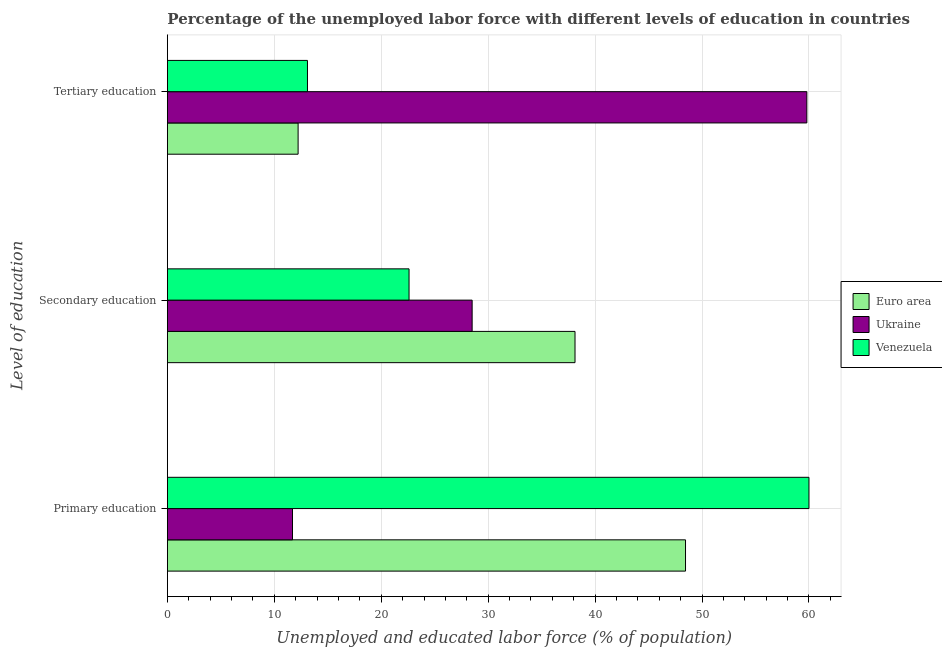How many different coloured bars are there?
Your answer should be very brief. 3. How many groups of bars are there?
Ensure brevity in your answer.  3. How many bars are there on the 3rd tick from the bottom?
Your answer should be very brief. 3. What is the label of the 3rd group of bars from the top?
Keep it short and to the point. Primary education. What is the percentage of labor force who received primary education in Ukraine?
Give a very brief answer. 11.7. Across all countries, what is the maximum percentage of labor force who received tertiary education?
Your answer should be compact. 59.8. Across all countries, what is the minimum percentage of labor force who received primary education?
Provide a succinct answer. 11.7. In which country was the percentage of labor force who received primary education maximum?
Keep it short and to the point. Venezuela. In which country was the percentage of labor force who received secondary education minimum?
Give a very brief answer. Venezuela. What is the total percentage of labor force who received secondary education in the graph?
Provide a succinct answer. 89.22. What is the difference between the percentage of labor force who received tertiary education in Ukraine and that in Venezuela?
Provide a succinct answer. 46.7. What is the difference between the percentage of labor force who received secondary education in Ukraine and the percentage of labor force who received primary education in Euro area?
Your response must be concise. -19.95. What is the average percentage of labor force who received secondary education per country?
Your answer should be very brief. 29.74. What is the difference between the percentage of labor force who received primary education and percentage of labor force who received tertiary education in Euro area?
Your answer should be compact. 36.23. In how many countries, is the percentage of labor force who received primary education greater than 16 %?
Give a very brief answer. 2. What is the ratio of the percentage of labor force who received tertiary education in Euro area to that in Venezuela?
Offer a terse response. 0.93. Is the percentage of labor force who received secondary education in Ukraine less than that in Venezuela?
Make the answer very short. No. What is the difference between the highest and the second highest percentage of labor force who received primary education?
Offer a terse response. 11.55. What is the difference between the highest and the lowest percentage of labor force who received secondary education?
Give a very brief answer. 15.52. Is the sum of the percentage of labor force who received secondary education in Ukraine and Venezuela greater than the maximum percentage of labor force who received tertiary education across all countries?
Offer a terse response. No. What does the 1st bar from the top in Primary education represents?
Your response must be concise. Venezuela. What does the 3rd bar from the bottom in Secondary education represents?
Make the answer very short. Venezuela. Is it the case that in every country, the sum of the percentage of labor force who received primary education and percentage of labor force who received secondary education is greater than the percentage of labor force who received tertiary education?
Your answer should be compact. No. How many countries are there in the graph?
Your response must be concise. 3. What is the difference between two consecutive major ticks on the X-axis?
Offer a very short reply. 10. Does the graph contain grids?
Keep it short and to the point. Yes. What is the title of the graph?
Keep it short and to the point. Percentage of the unemployed labor force with different levels of education in countries. What is the label or title of the X-axis?
Provide a succinct answer. Unemployed and educated labor force (% of population). What is the label or title of the Y-axis?
Provide a short and direct response. Level of education. What is the Unemployed and educated labor force (% of population) in Euro area in Primary education?
Your answer should be compact. 48.45. What is the Unemployed and educated labor force (% of population) in Ukraine in Primary education?
Your answer should be very brief. 11.7. What is the Unemployed and educated labor force (% of population) of Euro area in Secondary education?
Offer a very short reply. 38.12. What is the Unemployed and educated labor force (% of population) of Ukraine in Secondary education?
Keep it short and to the point. 28.5. What is the Unemployed and educated labor force (% of population) in Venezuela in Secondary education?
Ensure brevity in your answer.  22.6. What is the Unemployed and educated labor force (% of population) of Euro area in Tertiary education?
Give a very brief answer. 12.23. What is the Unemployed and educated labor force (% of population) of Ukraine in Tertiary education?
Ensure brevity in your answer.  59.8. What is the Unemployed and educated labor force (% of population) of Venezuela in Tertiary education?
Provide a succinct answer. 13.1. Across all Level of education, what is the maximum Unemployed and educated labor force (% of population) of Euro area?
Give a very brief answer. 48.45. Across all Level of education, what is the maximum Unemployed and educated labor force (% of population) of Ukraine?
Ensure brevity in your answer.  59.8. Across all Level of education, what is the maximum Unemployed and educated labor force (% of population) in Venezuela?
Provide a succinct answer. 60. Across all Level of education, what is the minimum Unemployed and educated labor force (% of population) in Euro area?
Offer a very short reply. 12.23. Across all Level of education, what is the minimum Unemployed and educated labor force (% of population) of Ukraine?
Your response must be concise. 11.7. Across all Level of education, what is the minimum Unemployed and educated labor force (% of population) of Venezuela?
Your answer should be compact. 13.1. What is the total Unemployed and educated labor force (% of population) in Euro area in the graph?
Your answer should be compact. 98.8. What is the total Unemployed and educated labor force (% of population) of Ukraine in the graph?
Your response must be concise. 100. What is the total Unemployed and educated labor force (% of population) of Venezuela in the graph?
Make the answer very short. 95.7. What is the difference between the Unemployed and educated labor force (% of population) in Euro area in Primary education and that in Secondary education?
Give a very brief answer. 10.33. What is the difference between the Unemployed and educated labor force (% of population) in Ukraine in Primary education and that in Secondary education?
Your answer should be very brief. -16.8. What is the difference between the Unemployed and educated labor force (% of population) of Venezuela in Primary education and that in Secondary education?
Provide a succinct answer. 37.4. What is the difference between the Unemployed and educated labor force (% of population) in Euro area in Primary education and that in Tertiary education?
Provide a succinct answer. 36.23. What is the difference between the Unemployed and educated labor force (% of population) in Ukraine in Primary education and that in Tertiary education?
Offer a very short reply. -48.1. What is the difference between the Unemployed and educated labor force (% of population) in Venezuela in Primary education and that in Tertiary education?
Keep it short and to the point. 46.9. What is the difference between the Unemployed and educated labor force (% of population) of Euro area in Secondary education and that in Tertiary education?
Offer a terse response. 25.9. What is the difference between the Unemployed and educated labor force (% of population) in Ukraine in Secondary education and that in Tertiary education?
Keep it short and to the point. -31.3. What is the difference between the Unemployed and educated labor force (% of population) of Venezuela in Secondary education and that in Tertiary education?
Your answer should be very brief. 9.5. What is the difference between the Unemployed and educated labor force (% of population) in Euro area in Primary education and the Unemployed and educated labor force (% of population) in Ukraine in Secondary education?
Your answer should be compact. 19.95. What is the difference between the Unemployed and educated labor force (% of population) in Euro area in Primary education and the Unemployed and educated labor force (% of population) in Venezuela in Secondary education?
Keep it short and to the point. 25.85. What is the difference between the Unemployed and educated labor force (% of population) in Ukraine in Primary education and the Unemployed and educated labor force (% of population) in Venezuela in Secondary education?
Provide a short and direct response. -10.9. What is the difference between the Unemployed and educated labor force (% of population) in Euro area in Primary education and the Unemployed and educated labor force (% of population) in Ukraine in Tertiary education?
Ensure brevity in your answer.  -11.35. What is the difference between the Unemployed and educated labor force (% of population) of Euro area in Primary education and the Unemployed and educated labor force (% of population) of Venezuela in Tertiary education?
Your answer should be very brief. 35.35. What is the difference between the Unemployed and educated labor force (% of population) in Euro area in Secondary education and the Unemployed and educated labor force (% of population) in Ukraine in Tertiary education?
Provide a short and direct response. -21.68. What is the difference between the Unemployed and educated labor force (% of population) in Euro area in Secondary education and the Unemployed and educated labor force (% of population) in Venezuela in Tertiary education?
Your answer should be very brief. 25.02. What is the average Unemployed and educated labor force (% of population) in Euro area per Level of education?
Your answer should be compact. 32.93. What is the average Unemployed and educated labor force (% of population) of Ukraine per Level of education?
Offer a terse response. 33.33. What is the average Unemployed and educated labor force (% of population) of Venezuela per Level of education?
Your response must be concise. 31.9. What is the difference between the Unemployed and educated labor force (% of population) of Euro area and Unemployed and educated labor force (% of population) of Ukraine in Primary education?
Keep it short and to the point. 36.75. What is the difference between the Unemployed and educated labor force (% of population) in Euro area and Unemployed and educated labor force (% of population) in Venezuela in Primary education?
Make the answer very short. -11.55. What is the difference between the Unemployed and educated labor force (% of population) in Ukraine and Unemployed and educated labor force (% of population) in Venezuela in Primary education?
Give a very brief answer. -48.3. What is the difference between the Unemployed and educated labor force (% of population) of Euro area and Unemployed and educated labor force (% of population) of Ukraine in Secondary education?
Provide a short and direct response. 9.62. What is the difference between the Unemployed and educated labor force (% of population) of Euro area and Unemployed and educated labor force (% of population) of Venezuela in Secondary education?
Your answer should be very brief. 15.52. What is the difference between the Unemployed and educated labor force (% of population) in Euro area and Unemployed and educated labor force (% of population) in Ukraine in Tertiary education?
Offer a terse response. -47.57. What is the difference between the Unemployed and educated labor force (% of population) of Euro area and Unemployed and educated labor force (% of population) of Venezuela in Tertiary education?
Your response must be concise. -0.87. What is the difference between the Unemployed and educated labor force (% of population) of Ukraine and Unemployed and educated labor force (% of population) of Venezuela in Tertiary education?
Make the answer very short. 46.7. What is the ratio of the Unemployed and educated labor force (% of population) of Euro area in Primary education to that in Secondary education?
Your answer should be compact. 1.27. What is the ratio of the Unemployed and educated labor force (% of population) in Ukraine in Primary education to that in Secondary education?
Give a very brief answer. 0.41. What is the ratio of the Unemployed and educated labor force (% of population) of Venezuela in Primary education to that in Secondary education?
Provide a succinct answer. 2.65. What is the ratio of the Unemployed and educated labor force (% of population) in Euro area in Primary education to that in Tertiary education?
Ensure brevity in your answer.  3.96. What is the ratio of the Unemployed and educated labor force (% of population) in Ukraine in Primary education to that in Tertiary education?
Offer a very short reply. 0.2. What is the ratio of the Unemployed and educated labor force (% of population) of Venezuela in Primary education to that in Tertiary education?
Offer a terse response. 4.58. What is the ratio of the Unemployed and educated labor force (% of population) in Euro area in Secondary education to that in Tertiary education?
Keep it short and to the point. 3.12. What is the ratio of the Unemployed and educated labor force (% of population) in Ukraine in Secondary education to that in Tertiary education?
Your answer should be compact. 0.48. What is the ratio of the Unemployed and educated labor force (% of population) in Venezuela in Secondary education to that in Tertiary education?
Your response must be concise. 1.73. What is the difference between the highest and the second highest Unemployed and educated labor force (% of population) of Euro area?
Provide a succinct answer. 10.33. What is the difference between the highest and the second highest Unemployed and educated labor force (% of population) of Ukraine?
Your response must be concise. 31.3. What is the difference between the highest and the second highest Unemployed and educated labor force (% of population) in Venezuela?
Provide a short and direct response. 37.4. What is the difference between the highest and the lowest Unemployed and educated labor force (% of population) of Euro area?
Offer a terse response. 36.23. What is the difference between the highest and the lowest Unemployed and educated labor force (% of population) in Ukraine?
Offer a terse response. 48.1. What is the difference between the highest and the lowest Unemployed and educated labor force (% of population) in Venezuela?
Make the answer very short. 46.9. 